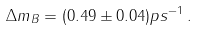Convert formula to latex. <formula><loc_0><loc_0><loc_500><loc_500>\Delta m _ { B } = ( 0 . 4 9 \pm 0 . 0 4 ) p s ^ { - 1 } \, .</formula> 